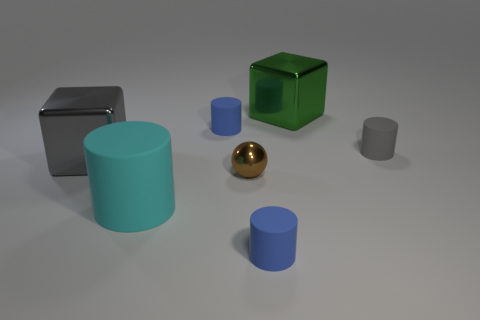There is a large green shiny thing; what shape is it?
Make the answer very short. Cube. The small thing that is in front of the big cyan cylinder is what color?
Give a very brief answer. Blue. There is a gray object behind the gray metallic block; does it have the same size as the tiny brown metallic object?
Provide a succinct answer. Yes. The gray thing that is the same shape as the green thing is what size?
Your answer should be very brief. Large. Is there any other thing that is the same size as the brown metal thing?
Your answer should be very brief. Yes. Do the gray metal thing and the large cyan thing have the same shape?
Make the answer very short. No. Are there fewer big matte objects that are to the right of the tiny metal sphere than tiny blue matte objects left of the cyan rubber object?
Your answer should be compact. No. There is a big gray thing; what number of things are on the right side of it?
Make the answer very short. 6. Do the small thing to the right of the green object and the large metal object that is right of the big gray metallic block have the same shape?
Offer a terse response. No. What is the material of the blue object in front of the thing that is right of the large metal thing to the right of the cyan matte object?
Provide a short and direct response. Rubber. 